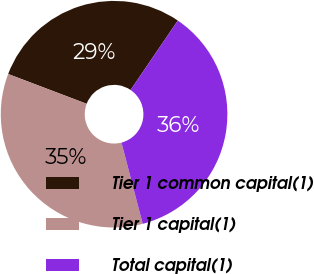<chart> <loc_0><loc_0><loc_500><loc_500><pie_chart><fcel>Tier 1 common capital(1)<fcel>Tier 1 capital(1)<fcel>Total capital(1)<nl><fcel>28.74%<fcel>34.84%<fcel>36.42%<nl></chart> 